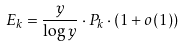Convert formula to latex. <formula><loc_0><loc_0><loc_500><loc_500>E _ { k } = \frac { y } { \log y } \cdot P _ { k } \cdot ( 1 + o ( 1 ) )</formula> 